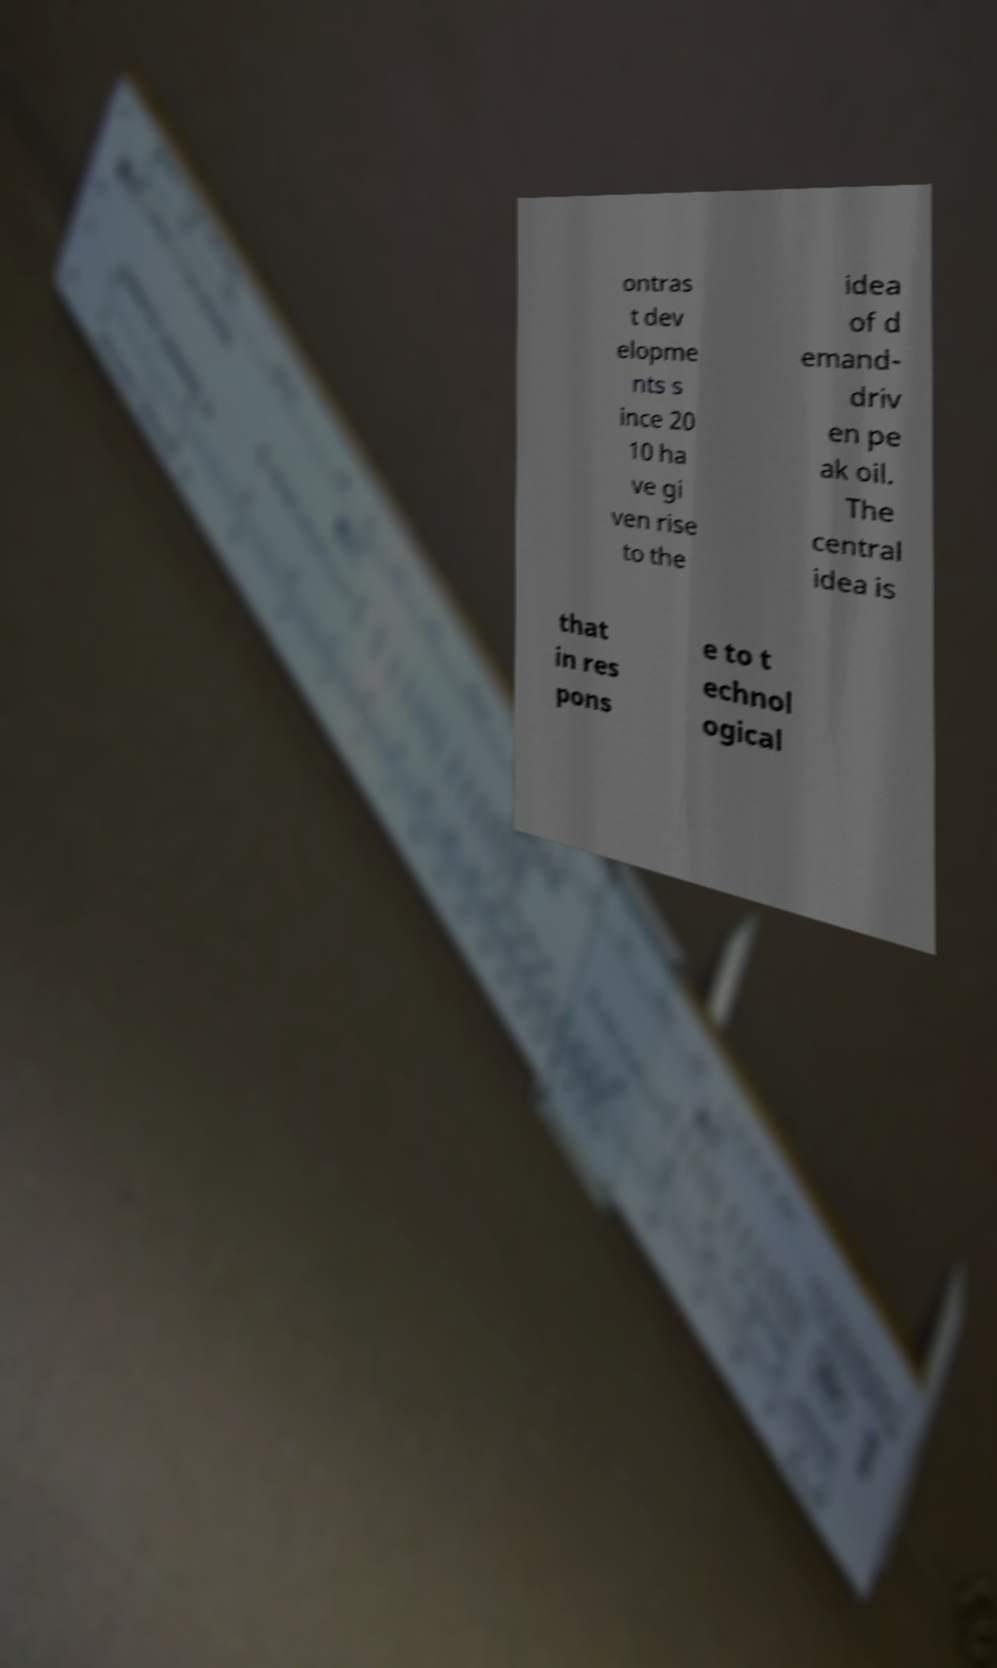Could you extract and type out the text from this image? ontras t dev elopme nts s ince 20 10 ha ve gi ven rise to the idea of d emand- driv en pe ak oil. The central idea is that in res pons e to t echnol ogical 